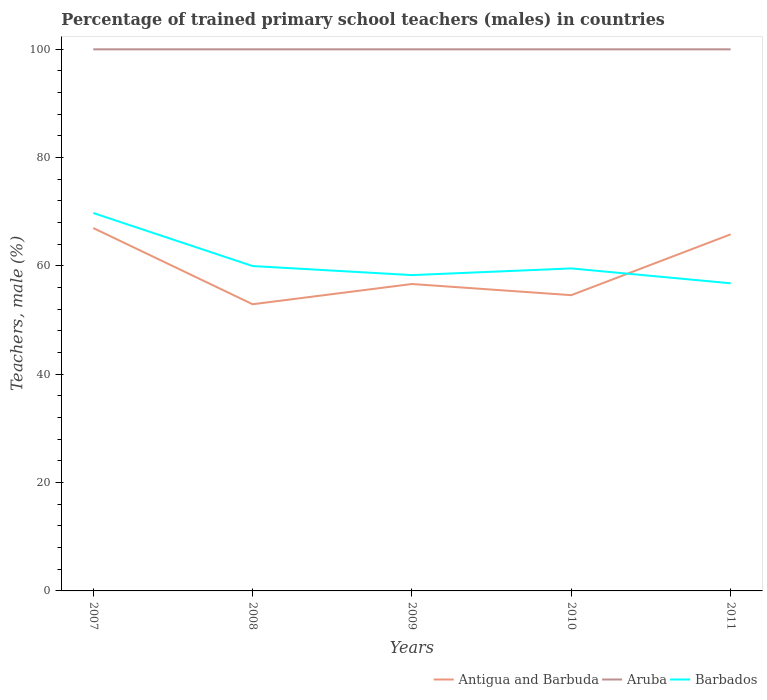Is the number of lines equal to the number of legend labels?
Offer a terse response. Yes. Across all years, what is the maximum percentage of trained primary school teachers (males) in Barbados?
Provide a succinct answer. 56.8. What is the total percentage of trained primary school teachers (males) in Barbados in the graph?
Provide a short and direct response. 1.67. What is the difference between the highest and the second highest percentage of trained primary school teachers (males) in Antigua and Barbuda?
Your response must be concise. 14.07. What is the difference between the highest and the lowest percentage of trained primary school teachers (males) in Aruba?
Your response must be concise. 0. How many years are there in the graph?
Provide a succinct answer. 5. What is the difference between two consecutive major ticks on the Y-axis?
Your answer should be very brief. 20. Does the graph contain grids?
Ensure brevity in your answer.  No. Where does the legend appear in the graph?
Keep it short and to the point. Bottom right. How are the legend labels stacked?
Your answer should be compact. Horizontal. What is the title of the graph?
Provide a succinct answer. Percentage of trained primary school teachers (males) in countries. Does "Dominican Republic" appear as one of the legend labels in the graph?
Your response must be concise. No. What is the label or title of the X-axis?
Ensure brevity in your answer.  Years. What is the label or title of the Y-axis?
Provide a succinct answer. Teachers, male (%). What is the Teachers, male (%) in Antigua and Barbuda in 2007?
Your answer should be very brief. 67. What is the Teachers, male (%) of Barbados in 2007?
Give a very brief answer. 69.78. What is the Teachers, male (%) in Antigua and Barbuda in 2008?
Keep it short and to the point. 52.93. What is the Teachers, male (%) of Aruba in 2008?
Keep it short and to the point. 100. What is the Teachers, male (%) in Barbados in 2008?
Make the answer very short. 59.99. What is the Teachers, male (%) in Antigua and Barbuda in 2009?
Your response must be concise. 56.67. What is the Teachers, male (%) of Barbados in 2009?
Your answer should be compact. 58.31. What is the Teachers, male (%) in Antigua and Barbuda in 2010?
Give a very brief answer. 54.61. What is the Teachers, male (%) in Aruba in 2010?
Your response must be concise. 100. What is the Teachers, male (%) in Barbados in 2010?
Provide a succinct answer. 59.55. What is the Teachers, male (%) of Antigua and Barbuda in 2011?
Give a very brief answer. 65.84. What is the Teachers, male (%) in Aruba in 2011?
Ensure brevity in your answer.  100. What is the Teachers, male (%) in Barbados in 2011?
Keep it short and to the point. 56.8. Across all years, what is the maximum Teachers, male (%) in Antigua and Barbuda?
Keep it short and to the point. 67. Across all years, what is the maximum Teachers, male (%) of Aruba?
Offer a terse response. 100. Across all years, what is the maximum Teachers, male (%) in Barbados?
Keep it short and to the point. 69.78. Across all years, what is the minimum Teachers, male (%) of Antigua and Barbuda?
Offer a terse response. 52.93. Across all years, what is the minimum Teachers, male (%) in Aruba?
Provide a short and direct response. 100. Across all years, what is the minimum Teachers, male (%) of Barbados?
Provide a succinct answer. 56.8. What is the total Teachers, male (%) of Antigua and Barbuda in the graph?
Keep it short and to the point. 297.05. What is the total Teachers, male (%) in Aruba in the graph?
Provide a short and direct response. 500. What is the total Teachers, male (%) in Barbados in the graph?
Offer a very short reply. 304.42. What is the difference between the Teachers, male (%) of Antigua and Barbuda in 2007 and that in 2008?
Your answer should be compact. 14.07. What is the difference between the Teachers, male (%) of Aruba in 2007 and that in 2008?
Keep it short and to the point. 0. What is the difference between the Teachers, male (%) in Barbados in 2007 and that in 2008?
Offer a terse response. 9.79. What is the difference between the Teachers, male (%) of Antigua and Barbuda in 2007 and that in 2009?
Provide a short and direct response. 10.34. What is the difference between the Teachers, male (%) in Aruba in 2007 and that in 2009?
Provide a succinct answer. 0. What is the difference between the Teachers, male (%) in Barbados in 2007 and that in 2009?
Give a very brief answer. 11.46. What is the difference between the Teachers, male (%) in Antigua and Barbuda in 2007 and that in 2010?
Give a very brief answer. 12.39. What is the difference between the Teachers, male (%) in Aruba in 2007 and that in 2010?
Your response must be concise. 0. What is the difference between the Teachers, male (%) in Barbados in 2007 and that in 2010?
Provide a short and direct response. 10.23. What is the difference between the Teachers, male (%) in Antigua and Barbuda in 2007 and that in 2011?
Keep it short and to the point. 1.17. What is the difference between the Teachers, male (%) of Barbados in 2007 and that in 2011?
Your response must be concise. 12.98. What is the difference between the Teachers, male (%) in Antigua and Barbuda in 2008 and that in 2009?
Give a very brief answer. -3.73. What is the difference between the Teachers, male (%) in Barbados in 2008 and that in 2009?
Offer a terse response. 1.67. What is the difference between the Teachers, male (%) of Antigua and Barbuda in 2008 and that in 2010?
Provide a succinct answer. -1.68. What is the difference between the Teachers, male (%) of Aruba in 2008 and that in 2010?
Ensure brevity in your answer.  0. What is the difference between the Teachers, male (%) of Barbados in 2008 and that in 2010?
Provide a succinct answer. 0.44. What is the difference between the Teachers, male (%) in Antigua and Barbuda in 2008 and that in 2011?
Make the answer very short. -12.9. What is the difference between the Teachers, male (%) in Aruba in 2008 and that in 2011?
Provide a succinct answer. 0. What is the difference between the Teachers, male (%) in Barbados in 2008 and that in 2011?
Provide a short and direct response. 3.18. What is the difference between the Teachers, male (%) of Antigua and Barbuda in 2009 and that in 2010?
Your answer should be compact. 2.06. What is the difference between the Teachers, male (%) in Barbados in 2009 and that in 2010?
Ensure brevity in your answer.  -1.23. What is the difference between the Teachers, male (%) in Antigua and Barbuda in 2009 and that in 2011?
Keep it short and to the point. -9.17. What is the difference between the Teachers, male (%) in Aruba in 2009 and that in 2011?
Give a very brief answer. 0. What is the difference between the Teachers, male (%) of Barbados in 2009 and that in 2011?
Your response must be concise. 1.51. What is the difference between the Teachers, male (%) of Antigua and Barbuda in 2010 and that in 2011?
Your response must be concise. -11.23. What is the difference between the Teachers, male (%) of Aruba in 2010 and that in 2011?
Offer a very short reply. 0. What is the difference between the Teachers, male (%) in Barbados in 2010 and that in 2011?
Ensure brevity in your answer.  2.75. What is the difference between the Teachers, male (%) in Antigua and Barbuda in 2007 and the Teachers, male (%) in Aruba in 2008?
Offer a terse response. -33. What is the difference between the Teachers, male (%) of Antigua and Barbuda in 2007 and the Teachers, male (%) of Barbados in 2008?
Offer a terse response. 7.02. What is the difference between the Teachers, male (%) in Aruba in 2007 and the Teachers, male (%) in Barbados in 2008?
Your response must be concise. 40.01. What is the difference between the Teachers, male (%) of Antigua and Barbuda in 2007 and the Teachers, male (%) of Aruba in 2009?
Provide a short and direct response. -33. What is the difference between the Teachers, male (%) in Antigua and Barbuda in 2007 and the Teachers, male (%) in Barbados in 2009?
Your answer should be very brief. 8.69. What is the difference between the Teachers, male (%) in Aruba in 2007 and the Teachers, male (%) in Barbados in 2009?
Provide a succinct answer. 41.69. What is the difference between the Teachers, male (%) in Antigua and Barbuda in 2007 and the Teachers, male (%) in Aruba in 2010?
Provide a short and direct response. -33. What is the difference between the Teachers, male (%) of Antigua and Barbuda in 2007 and the Teachers, male (%) of Barbados in 2010?
Provide a short and direct response. 7.46. What is the difference between the Teachers, male (%) of Aruba in 2007 and the Teachers, male (%) of Barbados in 2010?
Your answer should be compact. 40.45. What is the difference between the Teachers, male (%) in Antigua and Barbuda in 2007 and the Teachers, male (%) in Aruba in 2011?
Your response must be concise. -33. What is the difference between the Teachers, male (%) of Antigua and Barbuda in 2007 and the Teachers, male (%) of Barbados in 2011?
Keep it short and to the point. 10.2. What is the difference between the Teachers, male (%) in Aruba in 2007 and the Teachers, male (%) in Barbados in 2011?
Give a very brief answer. 43.2. What is the difference between the Teachers, male (%) of Antigua and Barbuda in 2008 and the Teachers, male (%) of Aruba in 2009?
Your answer should be very brief. -47.07. What is the difference between the Teachers, male (%) of Antigua and Barbuda in 2008 and the Teachers, male (%) of Barbados in 2009?
Your response must be concise. -5.38. What is the difference between the Teachers, male (%) of Aruba in 2008 and the Teachers, male (%) of Barbados in 2009?
Your answer should be very brief. 41.69. What is the difference between the Teachers, male (%) in Antigua and Barbuda in 2008 and the Teachers, male (%) in Aruba in 2010?
Make the answer very short. -47.07. What is the difference between the Teachers, male (%) in Antigua and Barbuda in 2008 and the Teachers, male (%) in Barbados in 2010?
Give a very brief answer. -6.61. What is the difference between the Teachers, male (%) in Aruba in 2008 and the Teachers, male (%) in Barbados in 2010?
Ensure brevity in your answer.  40.45. What is the difference between the Teachers, male (%) in Antigua and Barbuda in 2008 and the Teachers, male (%) in Aruba in 2011?
Your answer should be very brief. -47.07. What is the difference between the Teachers, male (%) in Antigua and Barbuda in 2008 and the Teachers, male (%) in Barbados in 2011?
Provide a short and direct response. -3.87. What is the difference between the Teachers, male (%) of Aruba in 2008 and the Teachers, male (%) of Barbados in 2011?
Offer a terse response. 43.2. What is the difference between the Teachers, male (%) in Antigua and Barbuda in 2009 and the Teachers, male (%) in Aruba in 2010?
Make the answer very short. -43.33. What is the difference between the Teachers, male (%) of Antigua and Barbuda in 2009 and the Teachers, male (%) of Barbados in 2010?
Provide a succinct answer. -2.88. What is the difference between the Teachers, male (%) of Aruba in 2009 and the Teachers, male (%) of Barbados in 2010?
Keep it short and to the point. 40.45. What is the difference between the Teachers, male (%) in Antigua and Barbuda in 2009 and the Teachers, male (%) in Aruba in 2011?
Offer a terse response. -43.33. What is the difference between the Teachers, male (%) in Antigua and Barbuda in 2009 and the Teachers, male (%) in Barbados in 2011?
Your response must be concise. -0.13. What is the difference between the Teachers, male (%) in Aruba in 2009 and the Teachers, male (%) in Barbados in 2011?
Provide a short and direct response. 43.2. What is the difference between the Teachers, male (%) of Antigua and Barbuda in 2010 and the Teachers, male (%) of Aruba in 2011?
Your answer should be compact. -45.39. What is the difference between the Teachers, male (%) in Antigua and Barbuda in 2010 and the Teachers, male (%) in Barbados in 2011?
Your answer should be very brief. -2.19. What is the difference between the Teachers, male (%) in Aruba in 2010 and the Teachers, male (%) in Barbados in 2011?
Offer a very short reply. 43.2. What is the average Teachers, male (%) in Antigua and Barbuda per year?
Keep it short and to the point. 59.41. What is the average Teachers, male (%) in Aruba per year?
Give a very brief answer. 100. What is the average Teachers, male (%) in Barbados per year?
Provide a short and direct response. 60.88. In the year 2007, what is the difference between the Teachers, male (%) of Antigua and Barbuda and Teachers, male (%) of Aruba?
Give a very brief answer. -33. In the year 2007, what is the difference between the Teachers, male (%) in Antigua and Barbuda and Teachers, male (%) in Barbados?
Offer a very short reply. -2.77. In the year 2007, what is the difference between the Teachers, male (%) of Aruba and Teachers, male (%) of Barbados?
Your answer should be compact. 30.22. In the year 2008, what is the difference between the Teachers, male (%) in Antigua and Barbuda and Teachers, male (%) in Aruba?
Provide a succinct answer. -47.07. In the year 2008, what is the difference between the Teachers, male (%) of Antigua and Barbuda and Teachers, male (%) of Barbados?
Offer a very short reply. -7.05. In the year 2008, what is the difference between the Teachers, male (%) in Aruba and Teachers, male (%) in Barbados?
Your answer should be compact. 40.01. In the year 2009, what is the difference between the Teachers, male (%) of Antigua and Barbuda and Teachers, male (%) of Aruba?
Your response must be concise. -43.33. In the year 2009, what is the difference between the Teachers, male (%) in Antigua and Barbuda and Teachers, male (%) in Barbados?
Offer a terse response. -1.65. In the year 2009, what is the difference between the Teachers, male (%) in Aruba and Teachers, male (%) in Barbados?
Offer a very short reply. 41.69. In the year 2010, what is the difference between the Teachers, male (%) in Antigua and Barbuda and Teachers, male (%) in Aruba?
Make the answer very short. -45.39. In the year 2010, what is the difference between the Teachers, male (%) of Antigua and Barbuda and Teachers, male (%) of Barbados?
Make the answer very short. -4.94. In the year 2010, what is the difference between the Teachers, male (%) of Aruba and Teachers, male (%) of Barbados?
Your response must be concise. 40.45. In the year 2011, what is the difference between the Teachers, male (%) of Antigua and Barbuda and Teachers, male (%) of Aruba?
Offer a very short reply. -34.16. In the year 2011, what is the difference between the Teachers, male (%) of Antigua and Barbuda and Teachers, male (%) of Barbados?
Keep it short and to the point. 9.03. In the year 2011, what is the difference between the Teachers, male (%) of Aruba and Teachers, male (%) of Barbados?
Make the answer very short. 43.2. What is the ratio of the Teachers, male (%) of Antigua and Barbuda in 2007 to that in 2008?
Offer a very short reply. 1.27. What is the ratio of the Teachers, male (%) in Barbados in 2007 to that in 2008?
Give a very brief answer. 1.16. What is the ratio of the Teachers, male (%) of Antigua and Barbuda in 2007 to that in 2009?
Provide a succinct answer. 1.18. What is the ratio of the Teachers, male (%) of Barbados in 2007 to that in 2009?
Offer a terse response. 1.2. What is the ratio of the Teachers, male (%) of Antigua and Barbuda in 2007 to that in 2010?
Give a very brief answer. 1.23. What is the ratio of the Teachers, male (%) in Barbados in 2007 to that in 2010?
Provide a short and direct response. 1.17. What is the ratio of the Teachers, male (%) of Antigua and Barbuda in 2007 to that in 2011?
Give a very brief answer. 1.02. What is the ratio of the Teachers, male (%) in Aruba in 2007 to that in 2011?
Your answer should be very brief. 1. What is the ratio of the Teachers, male (%) of Barbados in 2007 to that in 2011?
Your response must be concise. 1.23. What is the ratio of the Teachers, male (%) of Antigua and Barbuda in 2008 to that in 2009?
Your response must be concise. 0.93. What is the ratio of the Teachers, male (%) in Barbados in 2008 to that in 2009?
Your answer should be compact. 1.03. What is the ratio of the Teachers, male (%) in Antigua and Barbuda in 2008 to that in 2010?
Make the answer very short. 0.97. What is the ratio of the Teachers, male (%) of Barbados in 2008 to that in 2010?
Offer a very short reply. 1.01. What is the ratio of the Teachers, male (%) of Antigua and Barbuda in 2008 to that in 2011?
Keep it short and to the point. 0.8. What is the ratio of the Teachers, male (%) in Aruba in 2008 to that in 2011?
Keep it short and to the point. 1. What is the ratio of the Teachers, male (%) in Barbados in 2008 to that in 2011?
Make the answer very short. 1.06. What is the ratio of the Teachers, male (%) of Antigua and Barbuda in 2009 to that in 2010?
Your response must be concise. 1.04. What is the ratio of the Teachers, male (%) in Barbados in 2009 to that in 2010?
Give a very brief answer. 0.98. What is the ratio of the Teachers, male (%) of Antigua and Barbuda in 2009 to that in 2011?
Make the answer very short. 0.86. What is the ratio of the Teachers, male (%) of Aruba in 2009 to that in 2011?
Offer a terse response. 1. What is the ratio of the Teachers, male (%) of Barbados in 2009 to that in 2011?
Your answer should be compact. 1.03. What is the ratio of the Teachers, male (%) in Antigua and Barbuda in 2010 to that in 2011?
Your answer should be very brief. 0.83. What is the ratio of the Teachers, male (%) of Barbados in 2010 to that in 2011?
Keep it short and to the point. 1.05. What is the difference between the highest and the second highest Teachers, male (%) in Antigua and Barbuda?
Provide a short and direct response. 1.17. What is the difference between the highest and the second highest Teachers, male (%) of Barbados?
Provide a short and direct response. 9.79. What is the difference between the highest and the lowest Teachers, male (%) of Antigua and Barbuda?
Make the answer very short. 14.07. What is the difference between the highest and the lowest Teachers, male (%) in Aruba?
Give a very brief answer. 0. What is the difference between the highest and the lowest Teachers, male (%) of Barbados?
Offer a very short reply. 12.98. 